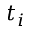Convert formula to latex. <formula><loc_0><loc_0><loc_500><loc_500>t _ { i }</formula> 